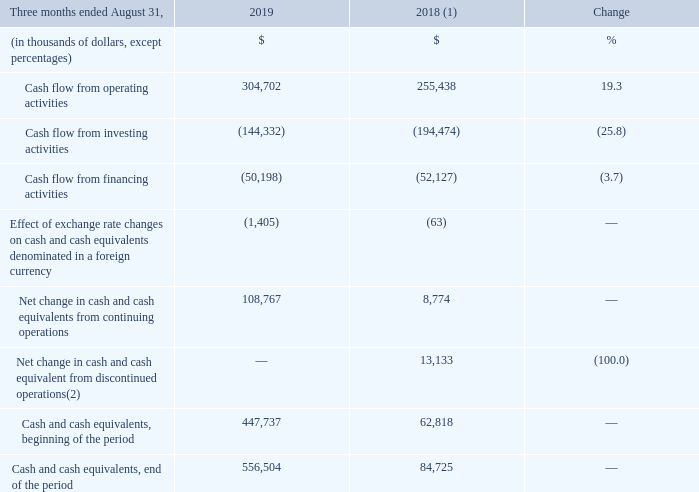CASH FLOW ANALYSIS
(1) Fiscal 2018 was restated to comply with IFRS 15 and to reflect a change in accounting policy as well as to reclassify results from Cogeco Peer 1 as discontinued operations. For further details, please consult the "Accounting policies" and "Discontinued operations" sections. (2) For further details on the Corporation's cash flow attributable to discontinued operations, please consult the "Discontinued operations" section.
OPERATING ACTIVITIES Fiscal 2019 fourth-quarter cash flow from operating activities increased by 19.3% compared to the same period of the prior year mainly from: • higher adjusted EBITDA; • the decreases in income taxes paid and financial expense paid; and • the increase in changes in non-cash operating activities primarily due to changes in working capital.
INVESTING ACTIVITIES Fiscal 2019 fourth-quarter investing activities decreased by 25.8% compared to the same period of the prior year mainly due to the acquisition of spectrum licenses in the Canadian broadband services segment in the comparable period of the prior year combined with a decrease in acquisitions of property, plant and equipment.
What was the increase in the operating activities in fourth-quarter 2019? 19.3%. What was reason for the increase in changes in non-cash operating activities? Primarily due to changes in working capital. What was the decrease in the investing activities in 2019? 25.8%. What was the increase / (decrease) in cash flow from operating activities from 2018 to 2019?
Answer scale should be: thousand. 304,702 - 255,438
Answer: 49264. What was the average Cash flow from investing activities?
Answer scale should be: thousand. -(144,332 + 194,474) / 2
Answer: -169403. What was the average Cash flow from financing activities?
Answer scale should be: thousand. -(50,198 + 52,127) / 2
Answer: -51162.5. 